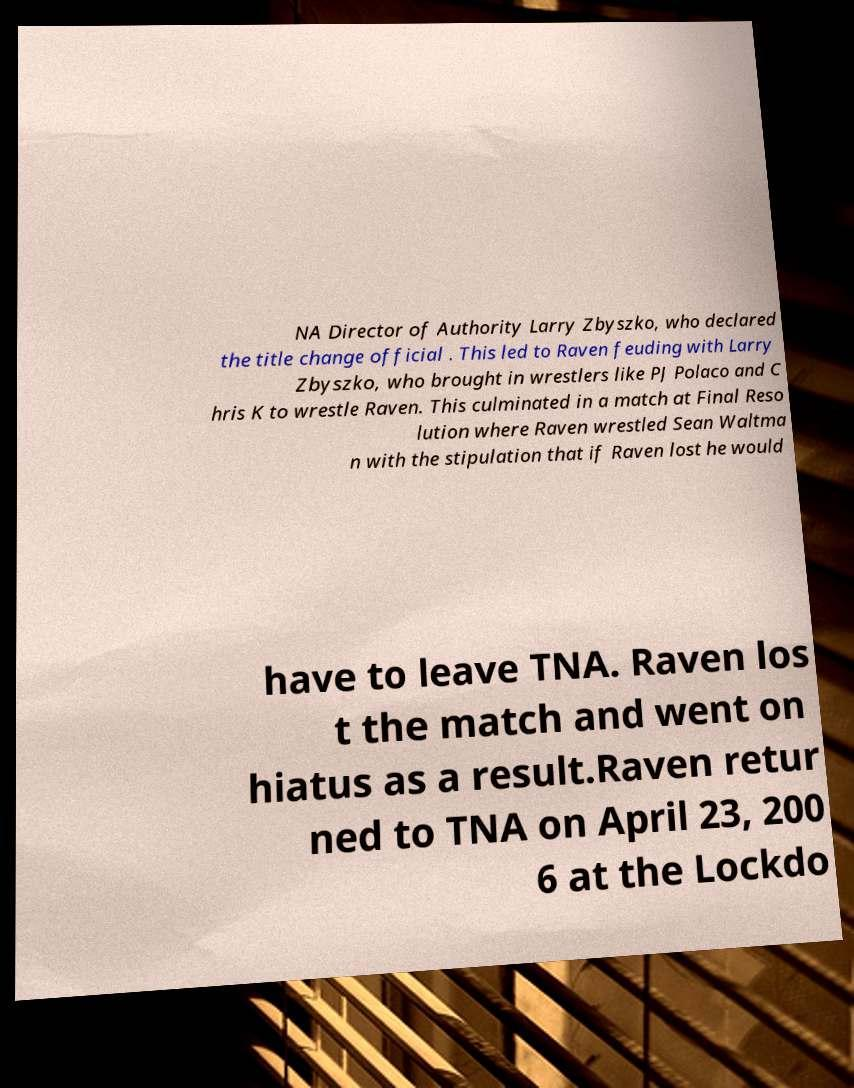Can you read and provide the text displayed in the image?This photo seems to have some interesting text. Can you extract and type it out for me? NA Director of Authority Larry Zbyszko, who declared the title change official . This led to Raven feuding with Larry Zbyszko, who brought in wrestlers like PJ Polaco and C hris K to wrestle Raven. This culminated in a match at Final Reso lution where Raven wrestled Sean Waltma n with the stipulation that if Raven lost he would have to leave TNA. Raven los t the match and went on hiatus as a result.Raven retur ned to TNA on April 23, 200 6 at the Lockdo 